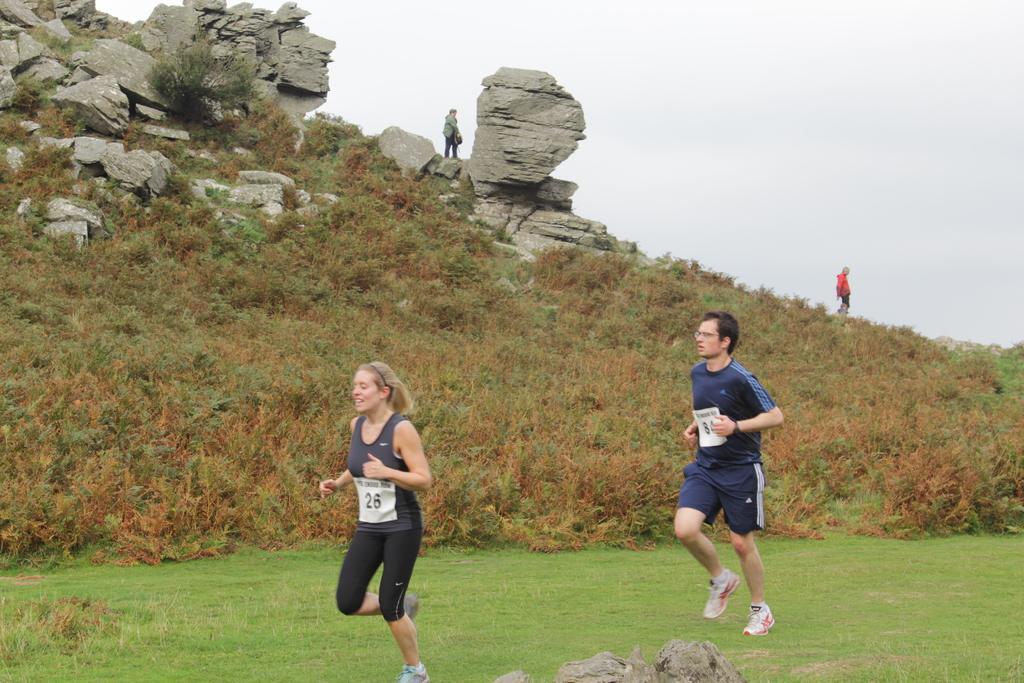Can you describe this image briefly? This image is taken outdoors. At the bottom of the image there is a ground with grass on it. At the top of the image there is a sky with clouds. In the middle of the image a man and a woman are running on the ground. In the background there is a hill with a few plants and rocks on it. There are two persons on the hill. 